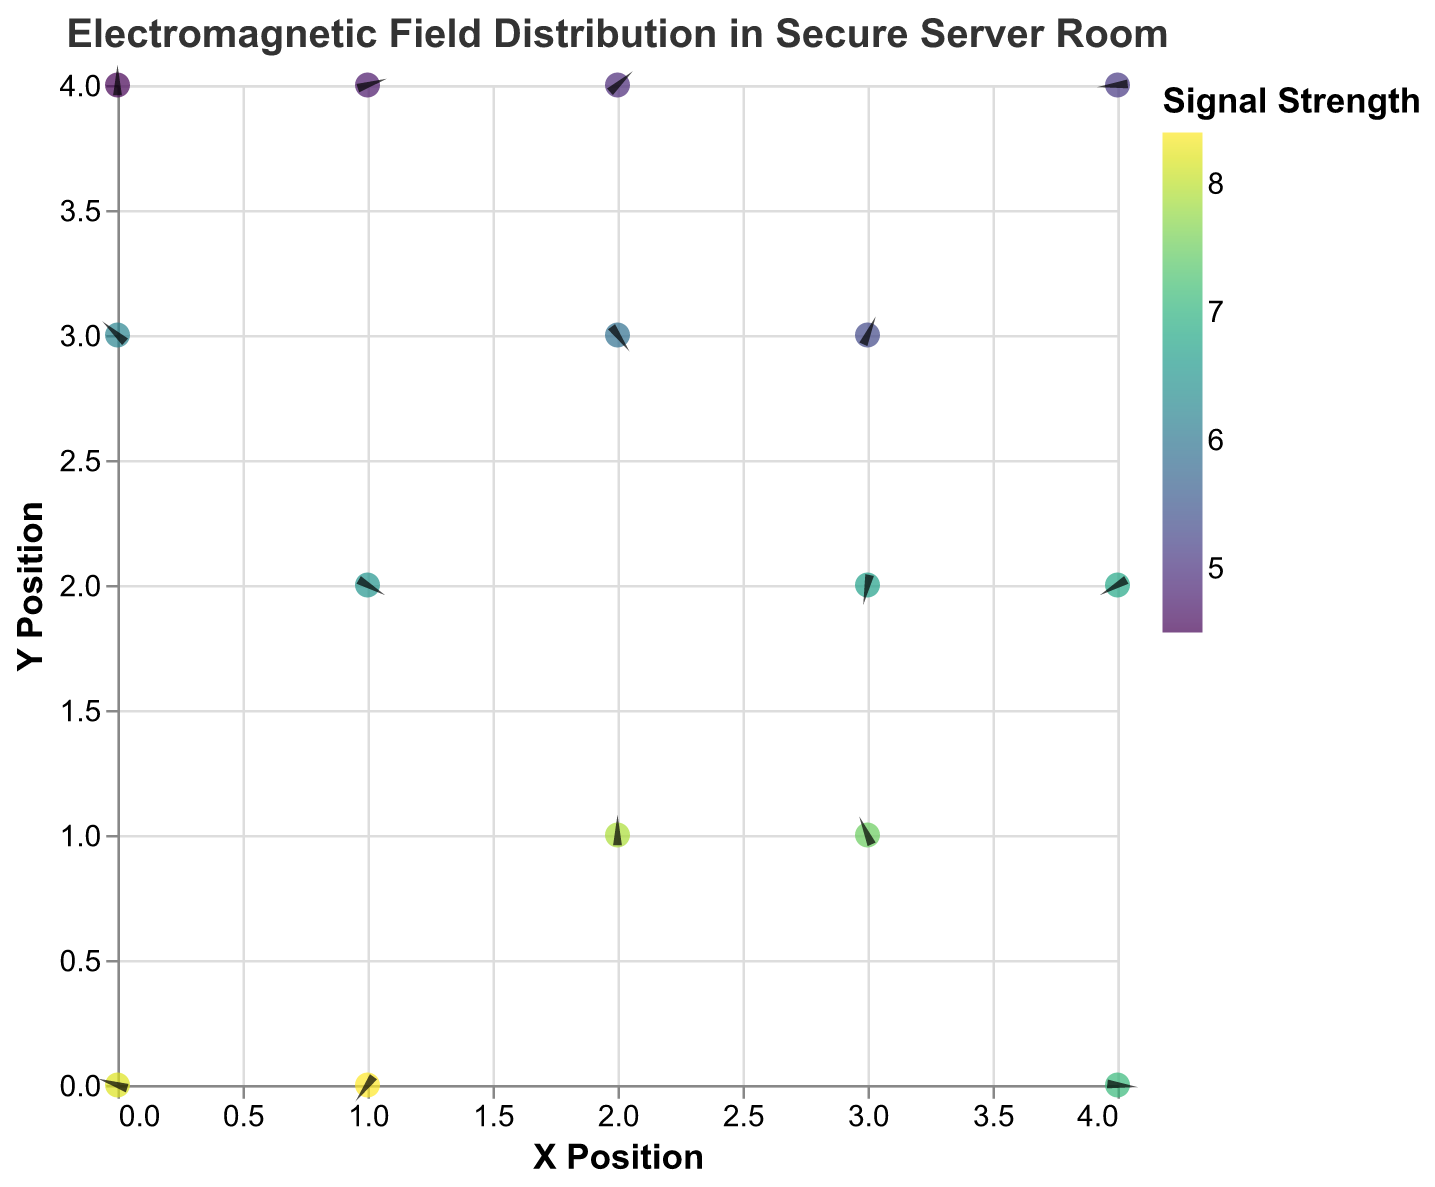What is the title of the figure? The title is usually located at the top of the figure and provides a brief description of what the plot represents. In this case, it is "Electromagnetic Field Distribution in Secure Server Room".
Answer: Electromagnetic Field Distribution in Secure Server Room How many data points are displayed in the figure? Counting the number of points in the given data values results in 15 points.
Answer: 15 Which data point has the highest signal strength, and what are its coordinates? By examining the 'strength' values in the data, the highest signal strength is 8.4, corresponding to the coordinates (1,0).
Answer: (1,0) What is the color scheme used to represent signal strength? The figure uses the "viridis" color scheme to indicate the varying signal strengths, as described in the explanation of the scale. Viridis is a perceptually uniform color map that ranges from yellow to green to blue.
Answer: Viridis Where is the signal strength the lowest? By looking at the data, the lowest signal strength is 4.5, which occurs at the coordinates (0,4).
Answer: (0,4) Which direction does the vector at position (3,3) point to? The vector at (3,3) has components 'u' and 'v' equal to -0.6 and -0.1, respectively, indicating it points to the left and slightly downward.
Answer: Left and downward How does the signal strength at (2,1) compare to that at (2,3)? The strength value at (2,1) is 7.9, and at (2,3) it is 5.9. 7.9 is greater than 5.9, so the signal strength at (2,1) is higher.
Answer: Higher What is the average signal strength of all data points? The average signal strength can be calculated by summing all the 'strength' values and dividing by the number of data points: (8.2 + 6.5 + 7.9 + 5.3 + 6.8 + 4.7 + 7.5 + 5.9 + 5.1 + 6.2 + 7.1 + 8.4 + 4.9 + 6.7 + 4.5) / 15 = 6.267 approximately.
Answer: 6.27 What is the total magnitude of the vector at (0,3)? The magnitude of a vector can be calculated using the formula sqrt(u^2 + v^2). For the vector at (0,3) where 'u' is 0.6 and 'v' is -0.2: sqrt(0.6^2 + (-0.2)^2) = sqrt(0.36 + 0.04) = sqrt(0.4) = 0.632 approximately.
Answer: 0.63 What are the coordinates of the data point with the second highest signal strength? After 8.4 at (1,0), the next highest strength value is 8.2 which corresponds to the coordinates (0,0).
Answer: (0,0) 